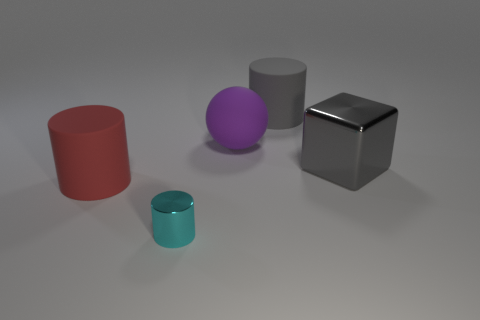Add 4 metal cylinders. How many objects exist? 9 Subtract all cylinders. How many objects are left? 2 Add 1 purple things. How many purple things exist? 2 Subtract 0 green cylinders. How many objects are left? 5 Subtract all tiny cyan cylinders. Subtract all large cyan metallic cylinders. How many objects are left? 4 Add 4 large red cylinders. How many large red cylinders are left? 5 